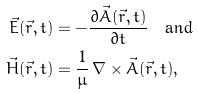<formula> <loc_0><loc_0><loc_500><loc_500>\vec { E } ( \vec { r } , t ) & = - \frac { \partial \vec { A } ( \vec { r } , t ) } { \partial t } \quad \text {and} \\ \vec { H } ( \vec { r } , t ) & = \frac { 1 } { \mu } \, \nabla \times \vec { A } ( \vec { r } , t ) ,</formula> 